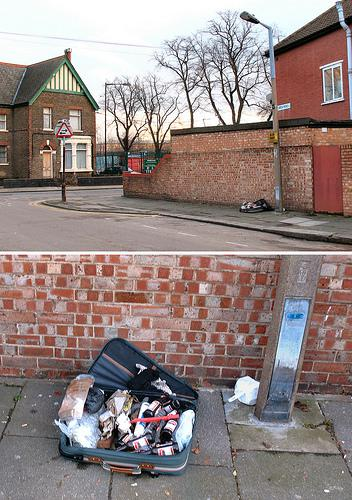Question: where is the open bag?
Choices:
A. Under the table.
B. On the bench.
C. On the counter.
D. Under the light post.
Answer with the letter. Answer: D Question: what is the shape of the street sign?
Choices:
A. Triangle.
B. Round.
C. Oval.
D. Square.
Answer with the letter. Answer: A Question: what are the buildings made of?
Choices:
A. Bricks.
B. Stone.
C. Wood.
D. Metal.
Answer with the letter. Answer: A Question: where is this picture taken?
Choices:
A. In a park.
B. At the zoo.
C. Outside a neighborhood.
D. In the woods.
Answer with the letter. Answer: C 